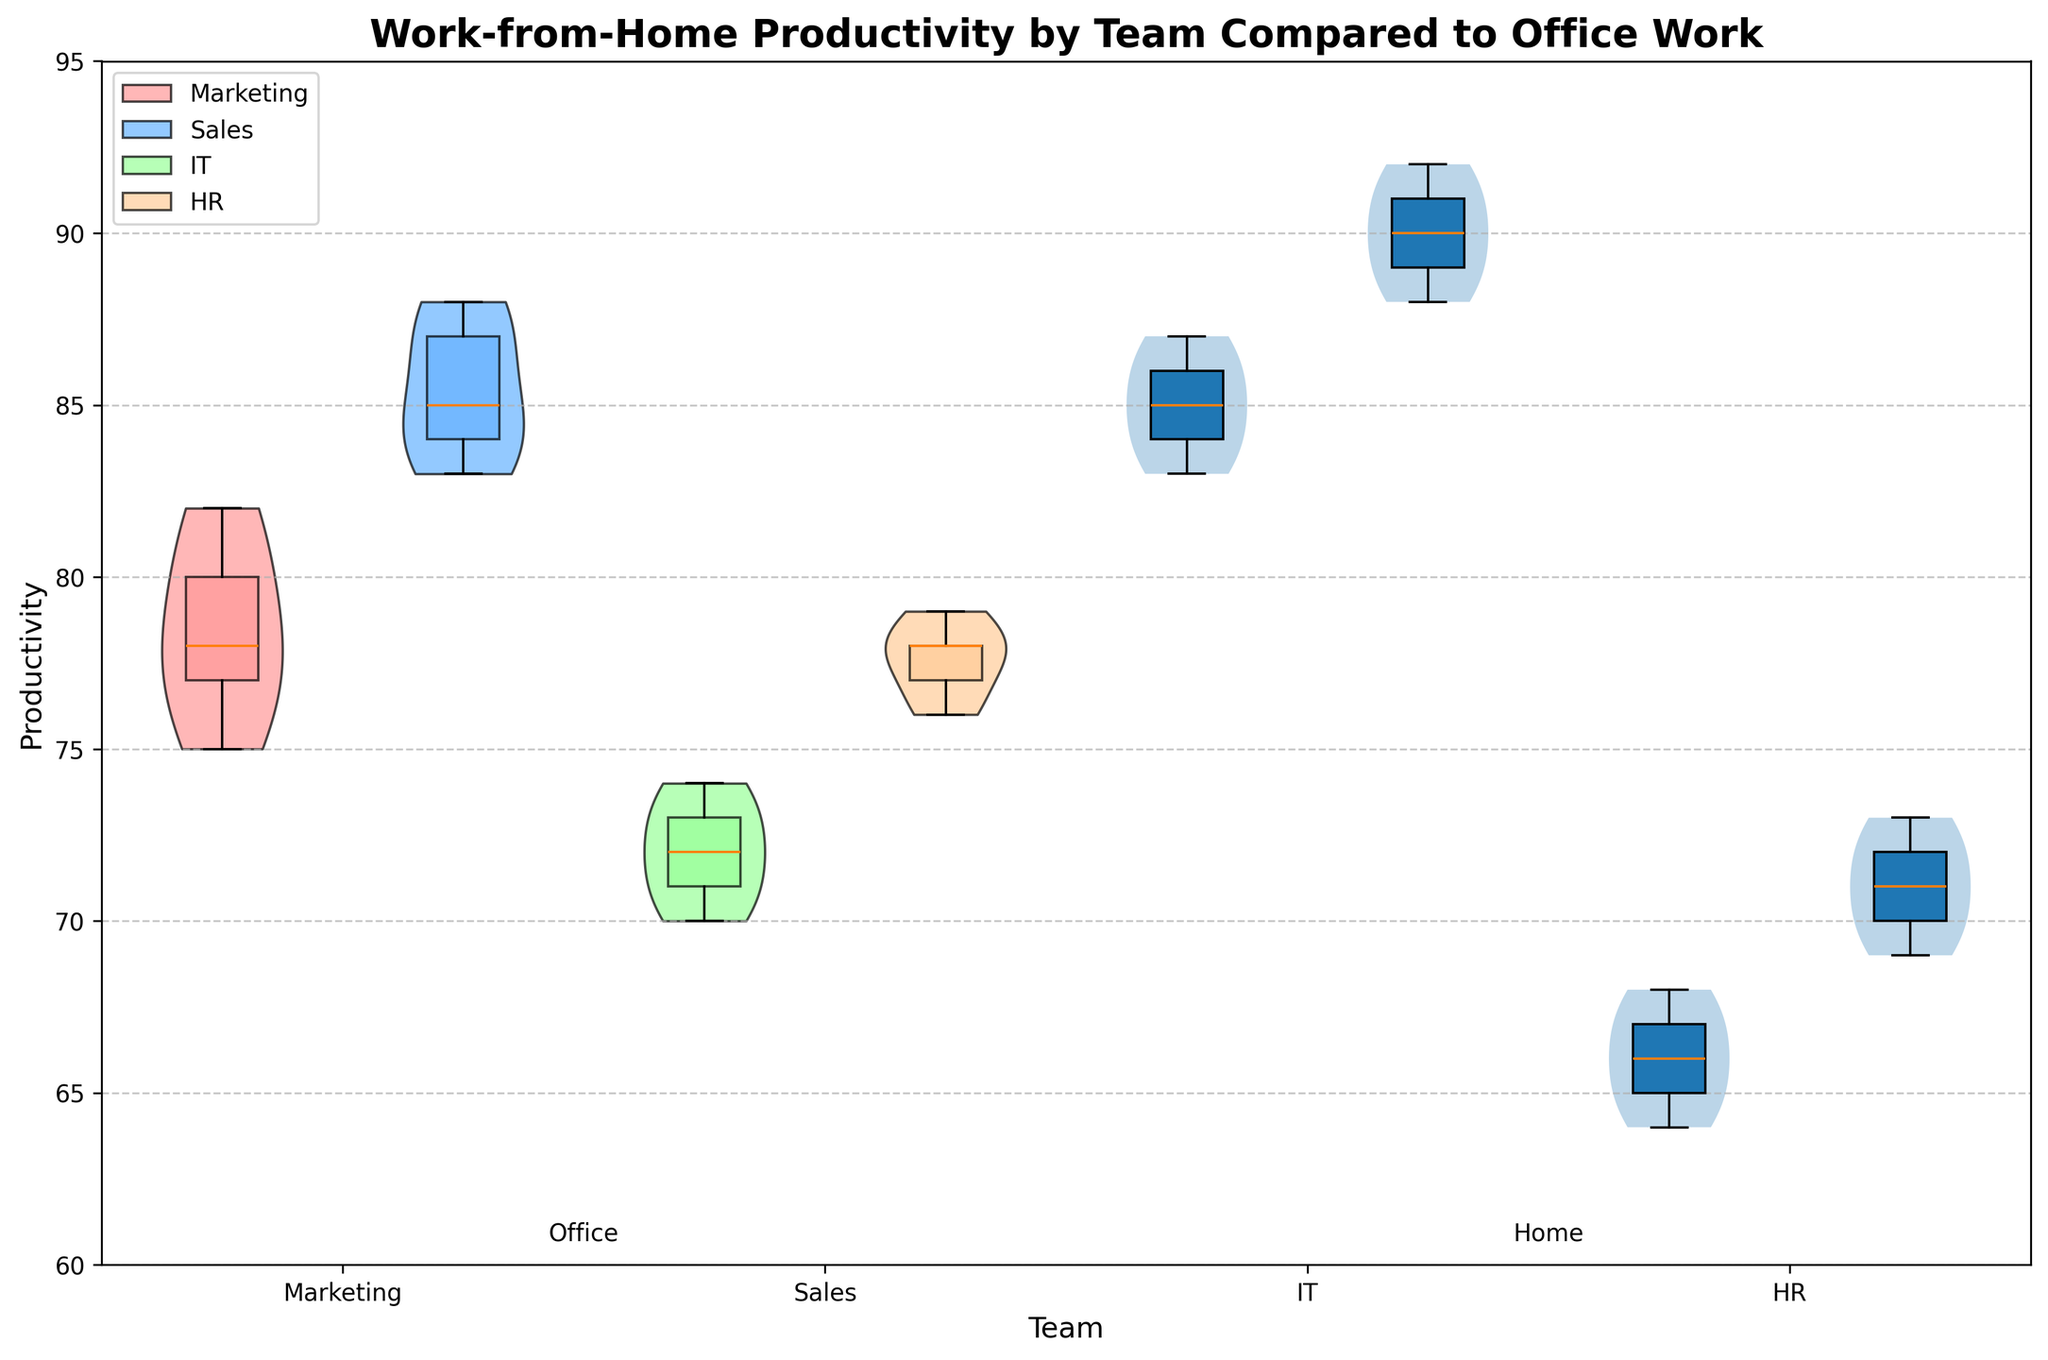What's the title of the chart? The title is usually at the top of the chart displayed in a larger and bold font
Answer: 'Work-from-Home Productivity by Team Compared to Office Work' What does the x-axis represent? The x-axis labels typically denote categories or groups being compared in the chart
Answer: Teams What does the y-axis represent? The y-axis shows the metric being measured and compared across the groups
Answer: Productivity Which team has the highest productivity working from home? The y-axis shows productivity levels, and by observing the maximum value for each team
Answer: IT What is the color used to represent the Marketing team in the chart? Each team is represented by a different color, identifiable in the legend
Answer: Red Which location generally has a higher productivity for the HR team? By comparing the distributions for Office and Home within HR, looking at the center and spread of the violins
Answer: Home What is the average productivity of the Sales team working from home? Sum the productivity values for Sales Home and divide by the number of data points: (78 + 77 + 79 + 76 + 78) / 5
Answer: 77.6 How does the highest productivity value for IT Home compare to IT Office? Compare the maximum value for IT Home to the highest in IT Office using the y-axis productivity levels
Answer: IT Home is higher Which team has the smallest spread in productivity for Office work? Spread refers to the range of the violin plot; look for the violin with the smallest vertical distance
Answer: HR Are there any teams for which remote work decreases productivity compared to office work? Compare the center and spread of violins for 'Office' and 'Home' for each team. Look for cases where Office values are generally higher
Answer: No How does the median productivity of Marketing Home compare to the average productivity of Sales Home? Identify the median line within the Marketing Home violin and calculate the average for Sales Home as shown earlier
Answer: Marketing Home median is higher 